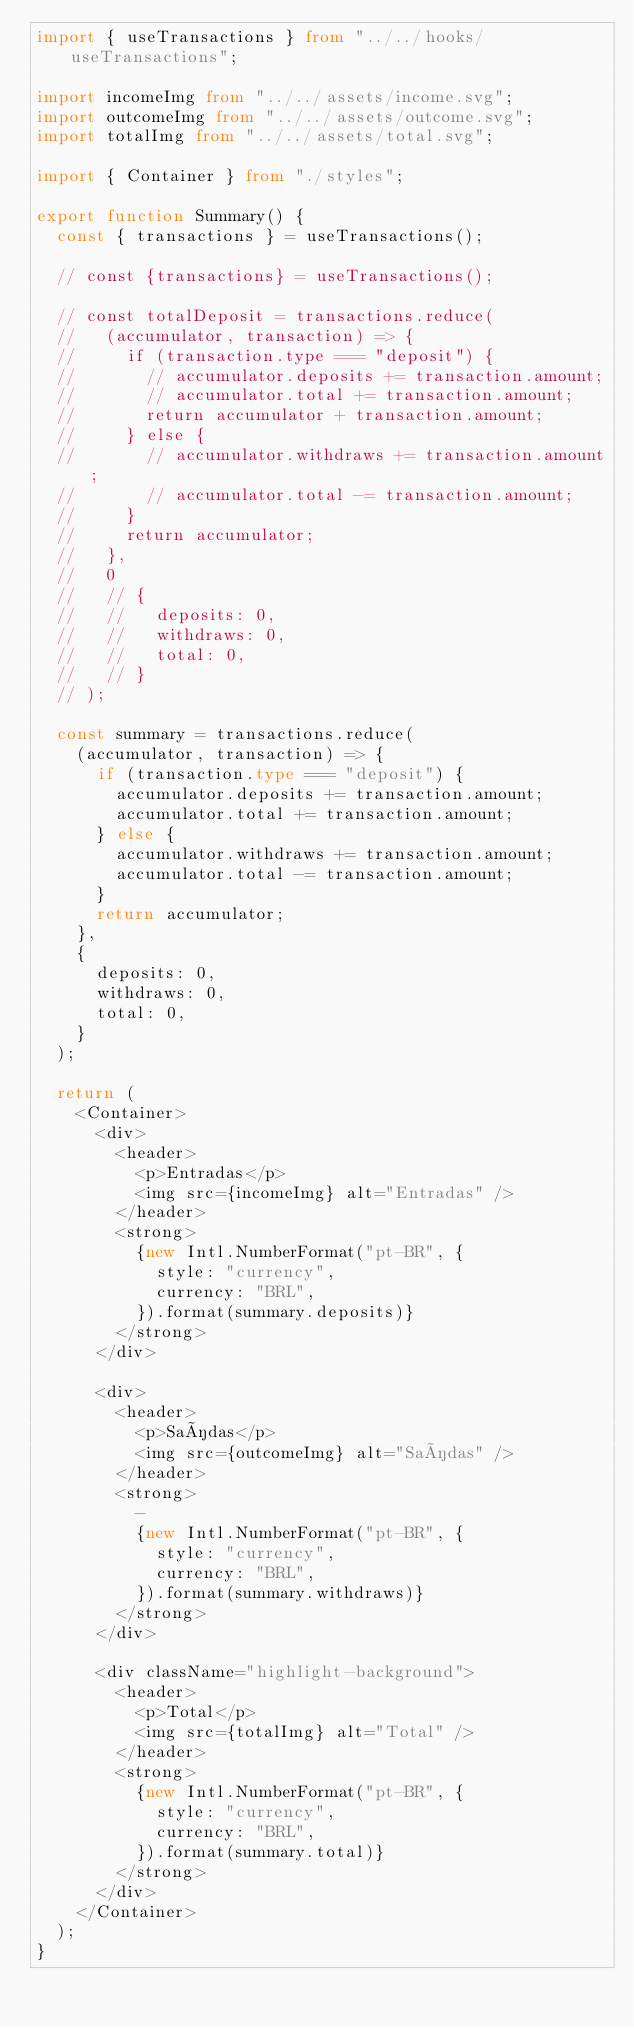<code> <loc_0><loc_0><loc_500><loc_500><_TypeScript_>import { useTransactions } from "../../hooks/useTransactions";

import incomeImg from "../../assets/income.svg";
import outcomeImg from "../../assets/outcome.svg";
import totalImg from "../../assets/total.svg";

import { Container } from "./styles";

export function Summary() {
  const { transactions } = useTransactions();

  // const {transactions} = useTransactions();

  // const totalDeposit = transactions.reduce(
  //   (accumulator, transaction) => {
  //     if (transaction.type === "deposit") {
  //       // accumulator.deposits += transaction.amount;
  //       // accumulator.total += transaction.amount;
  //       return accumulator + transaction.amount;
  //     } else {
  //       // accumulator.withdraws += transaction.amount;
  //       // accumulator.total -= transaction.amount;
  //     }
  //     return accumulator;
  //   },
  //   0
  //   // {
  //   //   deposits: 0,
  //   //   withdraws: 0,
  //   //   total: 0,
  //   // }
  // );

  const summary = transactions.reduce(
    (accumulator, transaction) => {
      if (transaction.type === "deposit") {
        accumulator.deposits += transaction.amount;
        accumulator.total += transaction.amount;
      } else {
        accumulator.withdraws += transaction.amount;
        accumulator.total -= transaction.amount;
      }
      return accumulator;
    },
    {
      deposits: 0,
      withdraws: 0,
      total: 0,
    }
  );

  return (
    <Container>
      <div>
        <header>
          <p>Entradas</p>
          <img src={incomeImg} alt="Entradas" />
        </header>
        <strong>
          {new Intl.NumberFormat("pt-BR", {
            style: "currency",
            currency: "BRL",
          }).format(summary.deposits)}
        </strong>
      </div>

      <div>
        <header>
          <p>Saídas</p>
          <img src={outcomeImg} alt="Saídas" />
        </header>
        <strong>
          -
          {new Intl.NumberFormat("pt-BR", {
            style: "currency",
            currency: "BRL",
          }).format(summary.withdraws)}
        </strong>
      </div>

      <div className="highlight-background">
        <header>
          <p>Total</p>
          <img src={totalImg} alt="Total" />
        </header>
        <strong>
          {new Intl.NumberFormat("pt-BR", {
            style: "currency",
            currency: "BRL",
          }).format(summary.total)}
        </strong>
      </div>
    </Container>
  );
}
</code> 